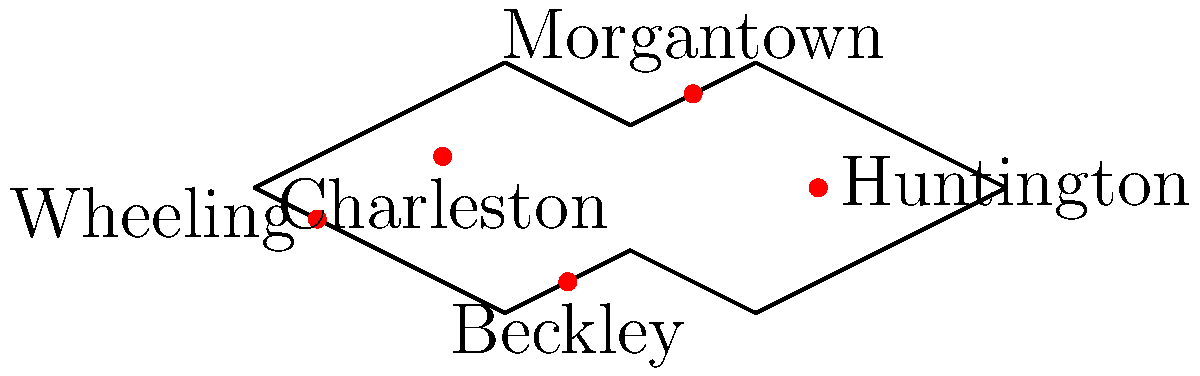Based on the point-based map of West Virginia showing the distribution of LGBTQ+ support organizations, which city appears to be the northernmost location for such an organization? To determine the northernmost location of an LGBTQ+ support organization in West Virginia, we need to follow these steps:

1. Identify all the marked locations on the map:
   - Charleston
   - Morgantown
   - Huntington
   - Beckley
   - Wheeling

2. Assess the relative positions of these locations:
   - Charleston is near the center of the state
   - Morgantown is in the northern part of the state
   - Huntington is in the western part of the state
   - Beckley is in the southern part of the state
   - Wheeling is in the northern part of the state, but not as far north as Morgantown

3. Compare the vertical positions of the points:
   - Morgantown's point is clearly higher (more northern) on the map than all other points

4. Conclude that Morgantown is the northernmost location marked on the map for an LGBTQ+ support organization in West Virginia.
Answer: Morgantown 